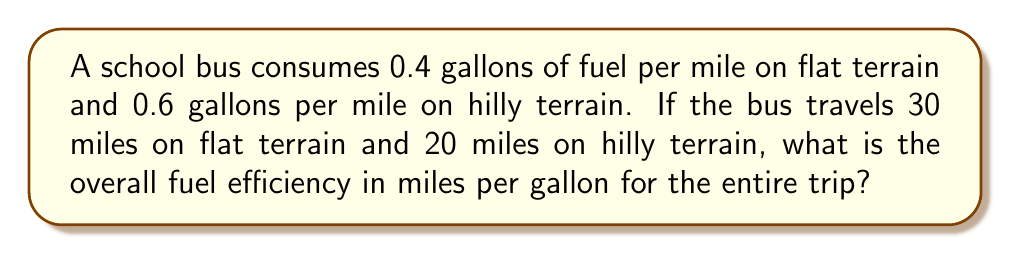Can you answer this question? Let's approach this step-by-step:

1) First, calculate the total fuel consumed:
   - For flat terrain: $30 \text{ miles} \times 0.4 \text{ gallons/mile} = 12 \text{ gallons}$
   - For hilly terrain: $20 \text{ miles} \times 0.6 \text{ gallons/mile} = 12 \text{ gallons}$
   - Total fuel consumed: $12 + 12 = 24 \text{ gallons}$

2) Calculate the total distance traveled:
   $30 \text{ miles} + 20 \text{ miles} = 50 \text{ miles}$

3) The fuel efficiency is given by the formula:
   $\text{Efficiency} = \frac{\text{Total Distance}}{\text{Total Fuel Consumed}}$

4) Plugging in our values:
   $$\text{Efficiency} = \frac{50 \text{ miles}}{24 \text{ gallons}} = \frac{25}{12} \text{ miles/gallon}$$

5) Simplifying the fraction:
   $$\frac{25}{12} = 2.0833... \text{ miles/gallon}$$

Therefore, the overall fuel efficiency for the entire trip is approximately 2.08 miles per gallon.
Answer: $\frac{25}{12} \approx 2.08 \text{ miles/gallon}$ 